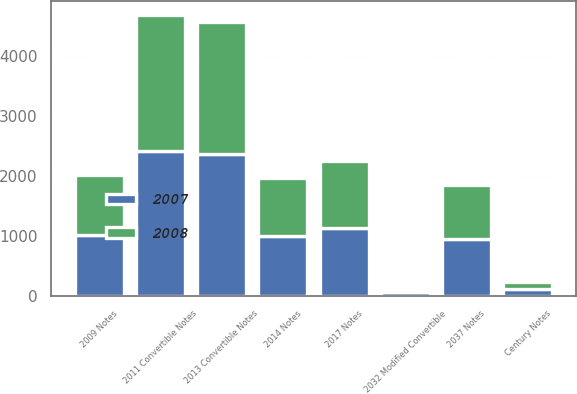Convert chart. <chart><loc_0><loc_0><loc_500><loc_500><stacked_bar_chart><ecel><fcel>2011 Convertible Notes<fcel>2013 Convertible Notes<fcel>2017 Notes<fcel>2014 Notes<fcel>2009 Notes<fcel>2037 Notes<fcel>2032 Modified Convertible<fcel>Century Notes<nl><fcel>2007<fcel>2415<fcel>2374<fcel>1140<fcel>994<fcel>1017<fcel>948<fcel>58<fcel>111<nl><fcel>2008<fcel>2282<fcel>2196<fcel>1105<fcel>970<fcel>994<fcel>897<fcel>54<fcel>119<nl></chart> 